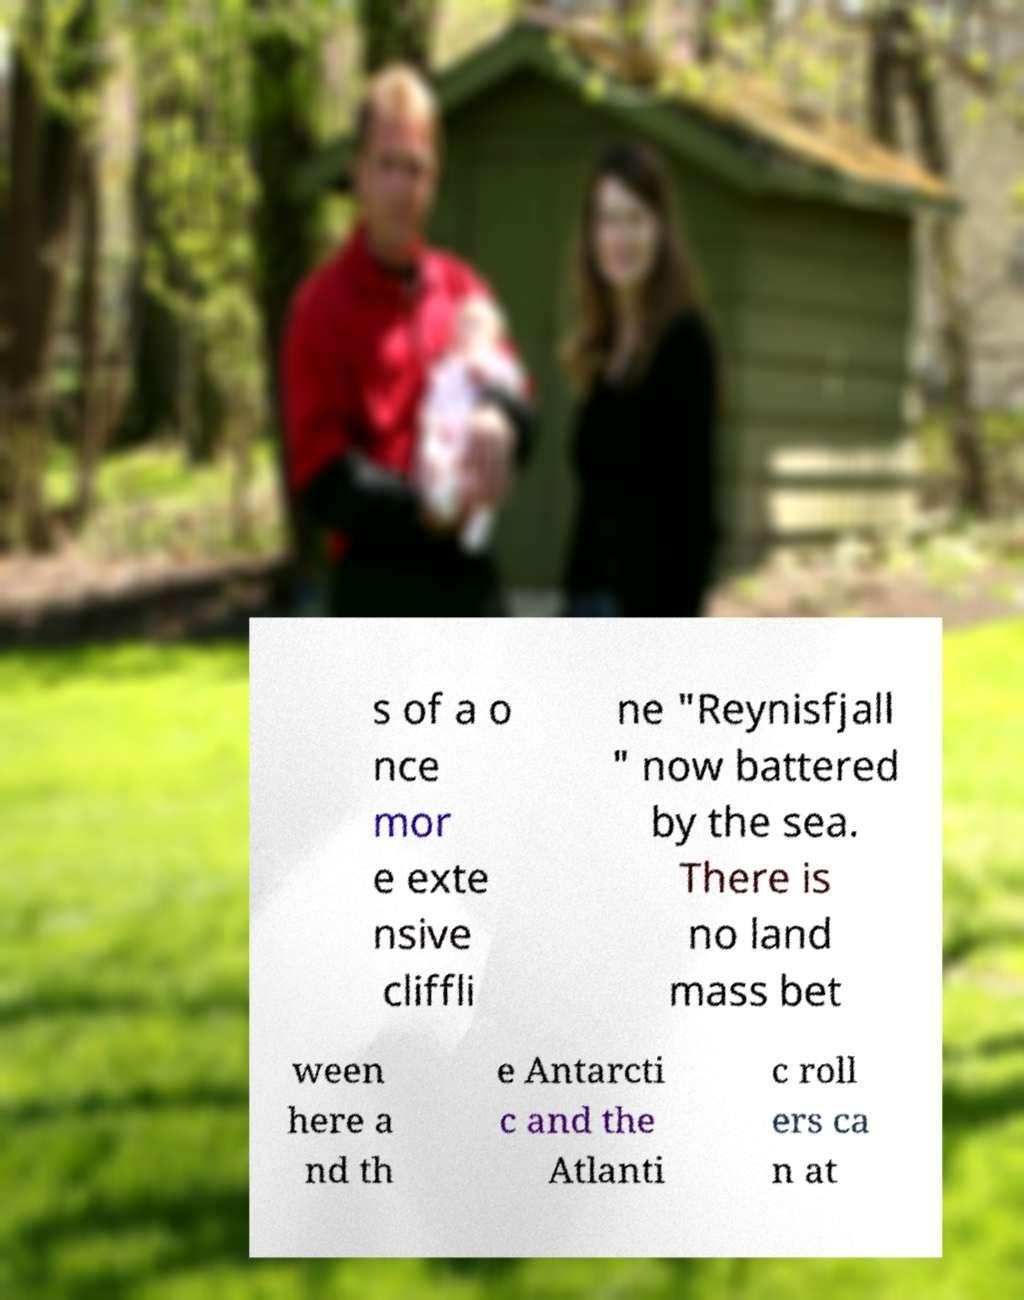There's text embedded in this image that I need extracted. Can you transcribe it verbatim? s of a o nce mor e exte nsive cliffli ne "Reynisfjall " now battered by the sea. There is no land mass bet ween here a nd th e Antarcti c and the Atlanti c roll ers ca n at 